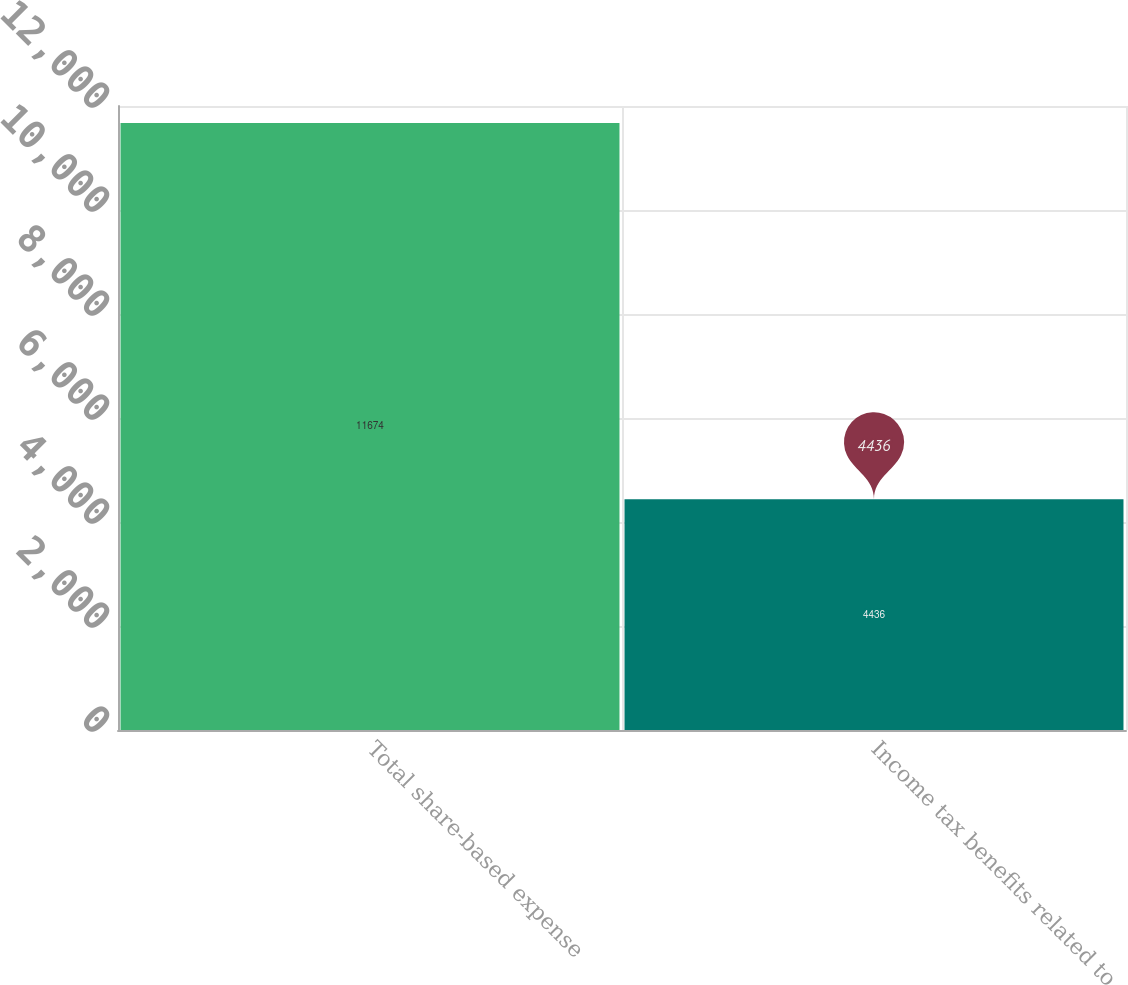Convert chart. <chart><loc_0><loc_0><loc_500><loc_500><bar_chart><fcel>Total share-based expense<fcel>Income tax benefits related to<nl><fcel>11674<fcel>4436<nl></chart> 